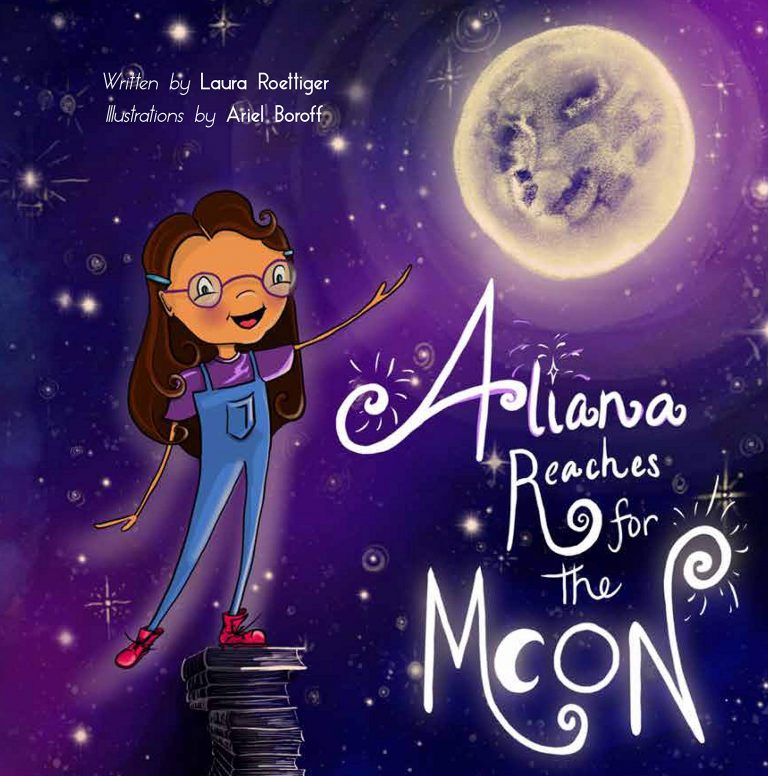Can you describe how the illustration style enhances the theme of the book? The illustration style of 'Aliana Reaches for the Moon' uses vibrant colors and whimsical designs, which evoke a sense of wonder and imagination. The starry background with soft gradients represents the boundless possibilities of the universe, stimulating a childlike fascination with the cosmos. The girl's large, expressive eyes and joyful demeanor add to the sense of optimism and adventure, making the theme of reaching for one's dreams more accessible and engaging for young readers. The illustrations do an excellent job of visually reinforcing the story's message about the importance of curiosity and ambition. 